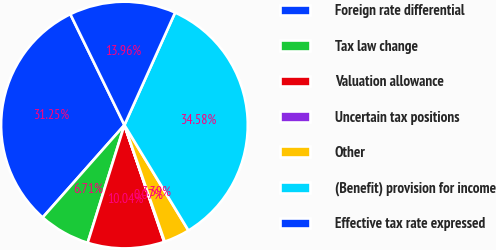Convert chart. <chart><loc_0><loc_0><loc_500><loc_500><pie_chart><fcel>Foreign rate differential<fcel>Tax law change<fcel>Valuation allowance<fcel>Uncertain tax positions<fcel>Other<fcel>(Benefit) provision for income<fcel>Effective tax rate expressed<nl><fcel>31.25%<fcel>6.71%<fcel>10.04%<fcel>0.07%<fcel>3.39%<fcel>34.58%<fcel>13.96%<nl></chart> 